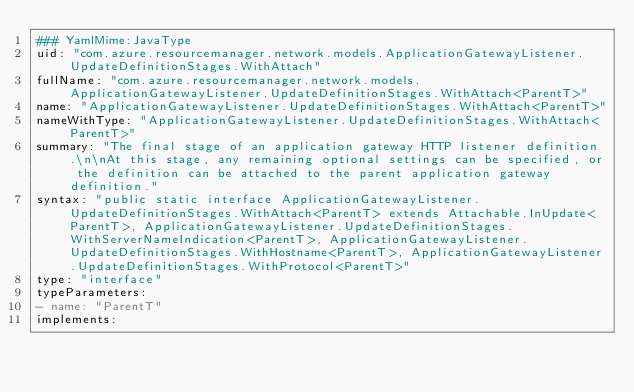<code> <loc_0><loc_0><loc_500><loc_500><_YAML_>### YamlMime:JavaType
uid: "com.azure.resourcemanager.network.models.ApplicationGatewayListener.UpdateDefinitionStages.WithAttach"
fullName: "com.azure.resourcemanager.network.models.ApplicationGatewayListener.UpdateDefinitionStages.WithAttach<ParentT>"
name: "ApplicationGatewayListener.UpdateDefinitionStages.WithAttach<ParentT>"
nameWithType: "ApplicationGatewayListener.UpdateDefinitionStages.WithAttach<ParentT>"
summary: "The final stage of an application gateway HTTP listener definition.\n\nAt this stage, any remaining optional settings can be specified, or the definition can be attached to the parent application gateway definition."
syntax: "public static interface ApplicationGatewayListener.UpdateDefinitionStages.WithAttach<ParentT> extends Attachable.InUpdate<ParentT>, ApplicationGatewayListener.UpdateDefinitionStages.WithServerNameIndication<ParentT>, ApplicationGatewayListener.UpdateDefinitionStages.WithHostname<ParentT>, ApplicationGatewayListener.UpdateDefinitionStages.WithProtocol<ParentT>"
type: "interface"
typeParameters:
- name: "ParentT"
implements:</code> 